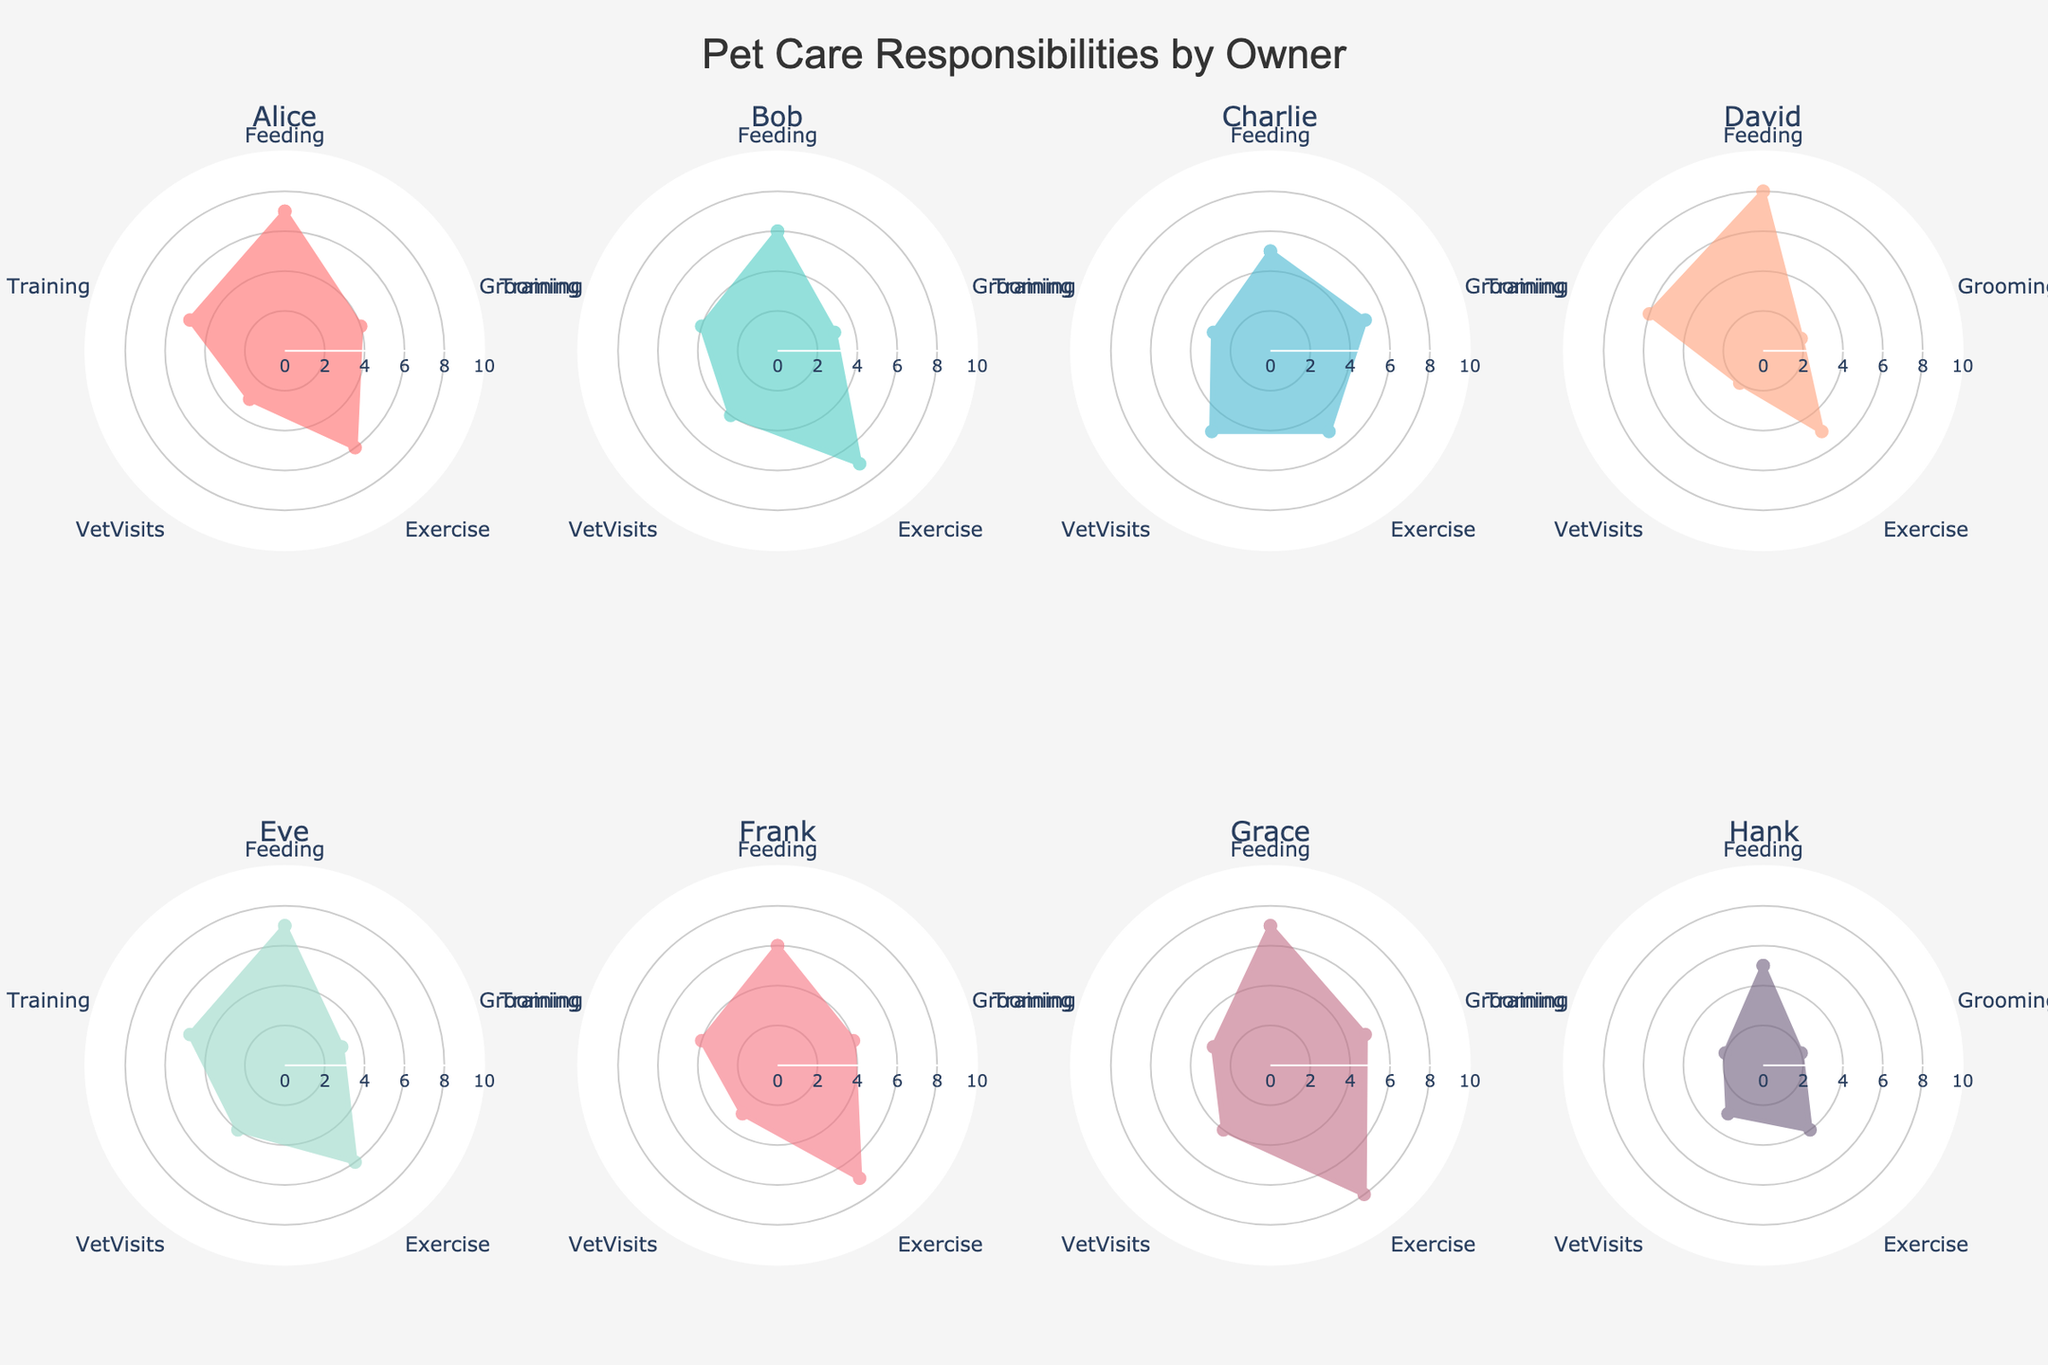Which owner has the highest value for Feeding? Look for the segment labeled "Feeding" and compare the values for all owners. David has a Feeding value of 8, which is the highest.
Answer: David What is the average value of Exercise across all owners? Add up the Exercise values (6 for Alice, 7 for Bob, 5 for Charlie, 5 for David, 6 for Eve, 7 for Frank, 8 for Grace, 4 for Hank). The total is 48. Divide by the number of owners, which is 8. The average value is 48/8 = 6.
Answer: 6 Who has the most even distribution of responsibilities across all categories? Identify the owner whose radar chart is closest to a regular pentagon shape, indicating evenly distributed values. Charlie's values are all 5, indicating the most even distribution.
Answer: Charlie Which owners have the same value for Vet Visits? Compare the Vet Visits values. Alice, Frank, and Hank all have a value of 3 in Vet Visits.
Answer: Alice, Frank, Hank How does David's Grooming value compare to Grace's Grooming value? Compare the Grooming values of David (2) and Grace (5). Grace's Grooming value is higher than David's.
Answer: Grace's value is higher What is Alice's total score for all categories? Add Alice's values: Feeding (7) + Grooming (4) + Exercise (6) + Vet Visits (3) + Training (5). The total score is 7 + 4 + 6 + 3 + 5 = 25.
Answer: 25 Among all owners, who spends the most effort on Training? Compare the Training values. David has the highest value for Training, which is 6.
Answer: David What is the difference in Exercise values between the highest and lowest scoring owners? The highest Exercise value is 8 (Grace), and the lowest is 4 (Hank). The difference is 8 - 4 = 4.
Answer: 4 Who has the highest combined score for Feeding and Exercise? Add the Feeding and Exercise values for all owners. Grace has 7 (Feeding) + 8 (Exercise) = 15, which is the highest combined score.
Answer: Grace Which owner does the least Grooming? Look for the owner with the lowest Grooming value. David and Hank both have a Grooming value of 2, which is the lowest.
Answer: David, Hank 